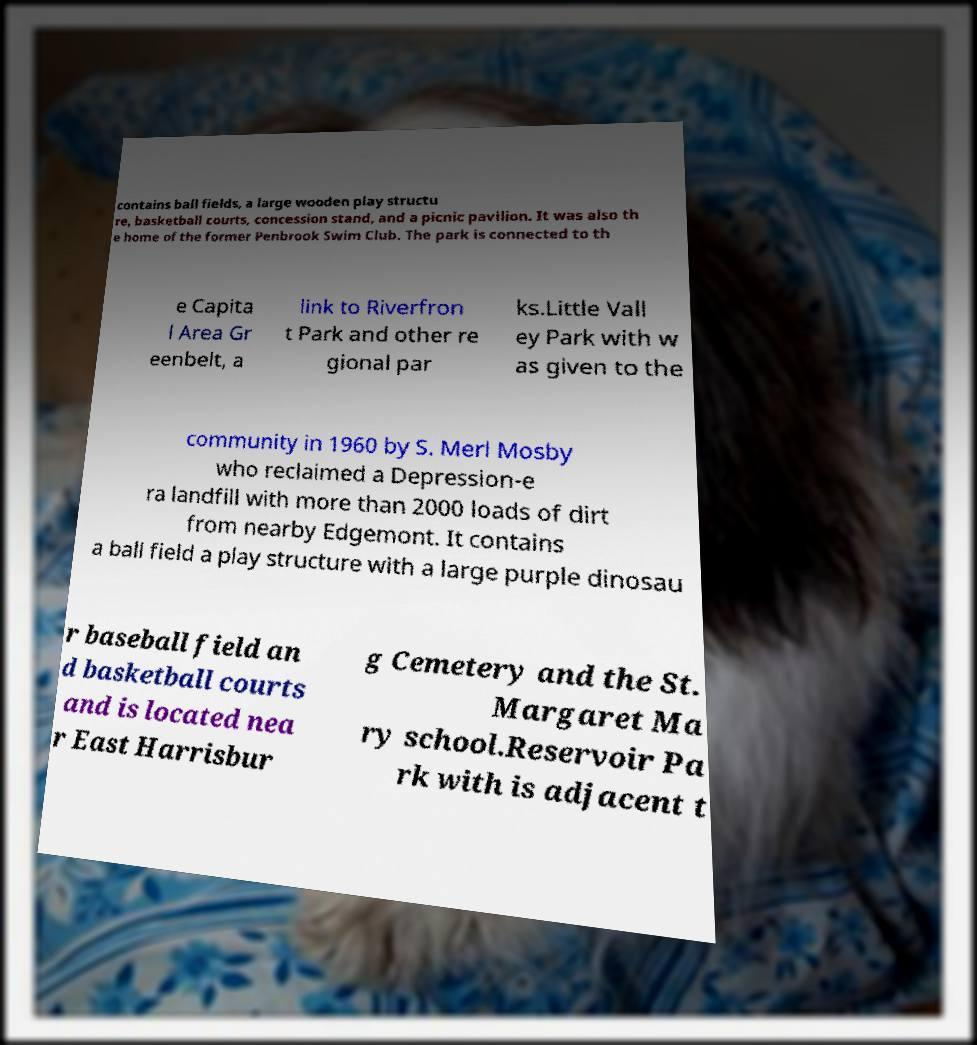Please identify and transcribe the text found in this image. contains ball fields, a large wooden play structu re, basketball courts, concession stand, and a picnic pavilion. It was also th e home of the former Penbrook Swim Club. The park is connected to th e Capita l Area Gr eenbelt, a link to Riverfron t Park and other re gional par ks.Little Vall ey Park with w as given to the community in 1960 by S. Merl Mosby who reclaimed a Depression-e ra landfill with more than 2000 loads of dirt from nearby Edgemont. It contains a ball field a play structure with a large purple dinosau r baseball field an d basketball courts and is located nea r East Harrisbur g Cemetery and the St. Margaret Ma ry school.Reservoir Pa rk with is adjacent t 